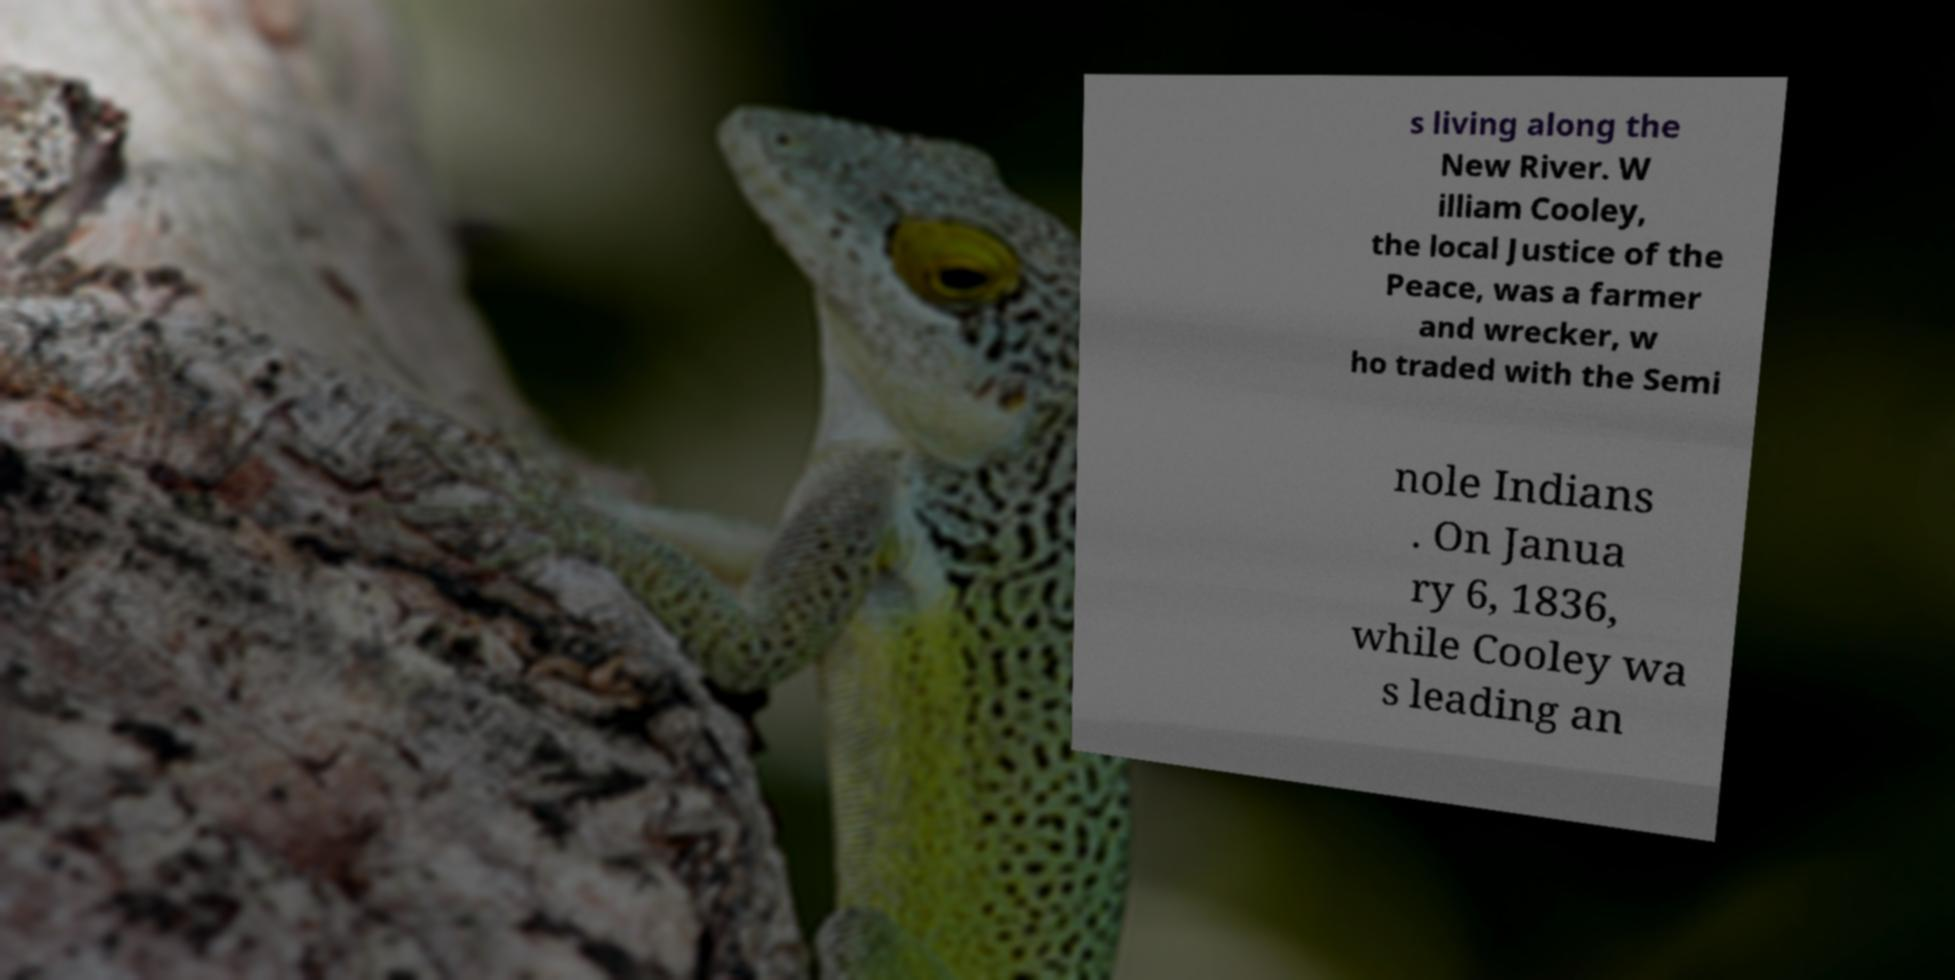Please read and relay the text visible in this image. What does it say? s living along the New River. W illiam Cooley, the local Justice of the Peace, was a farmer and wrecker, w ho traded with the Semi nole Indians . On Janua ry 6, 1836, while Cooley wa s leading an 